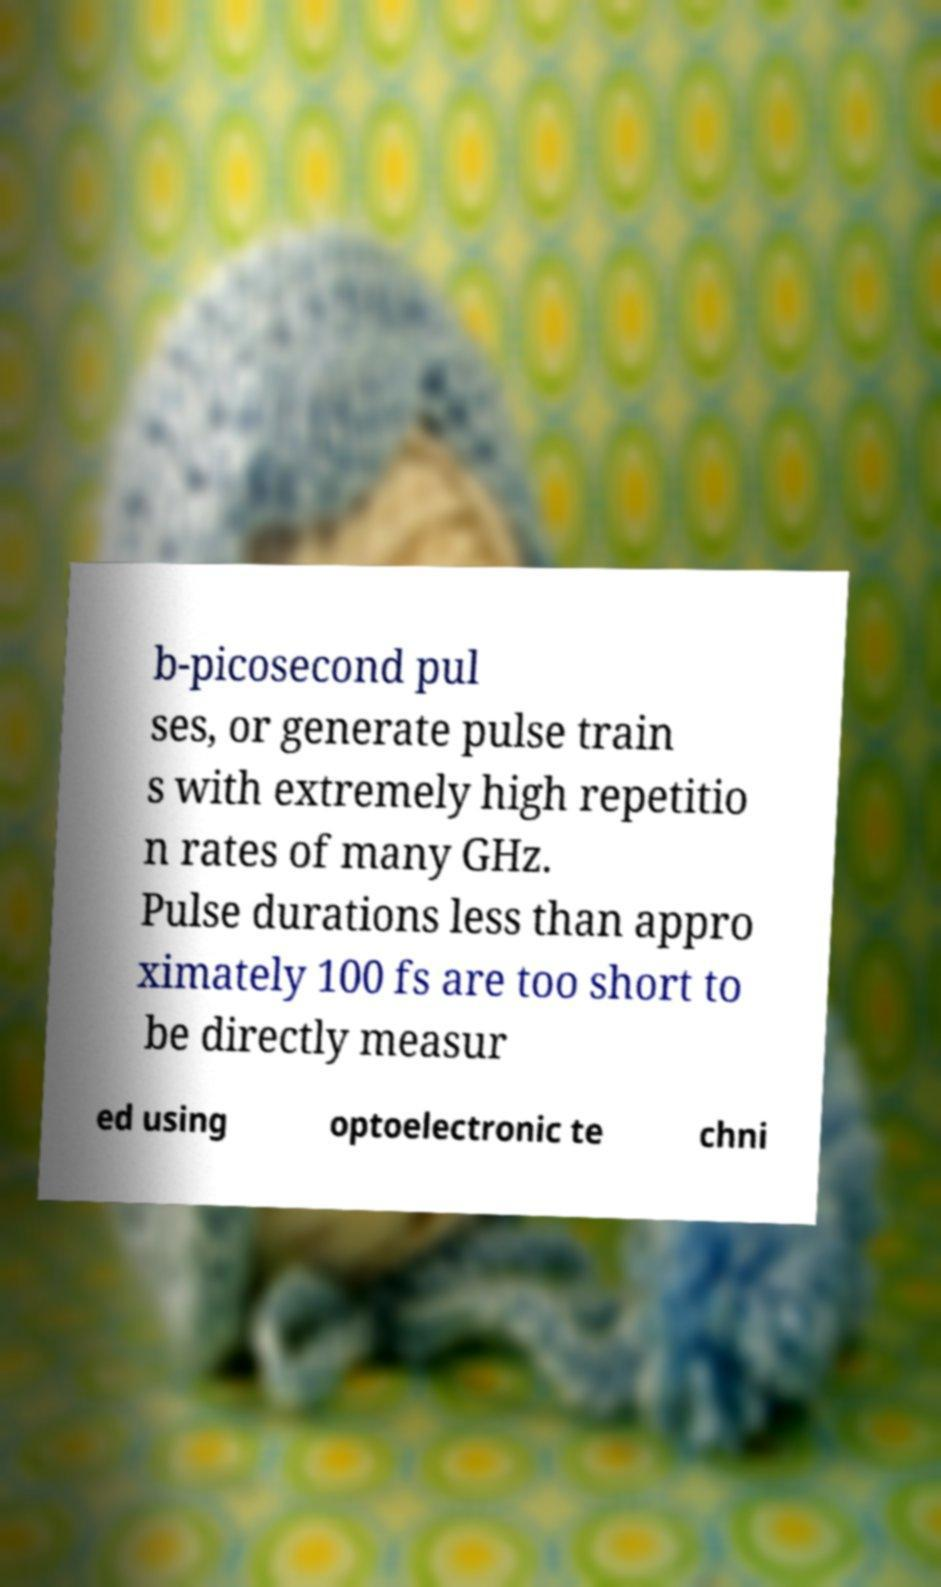For documentation purposes, I need the text within this image transcribed. Could you provide that? b-picosecond pul ses, or generate pulse train s with extremely high repetitio n rates of many GHz. Pulse durations less than appro ximately 100 fs are too short to be directly measur ed using optoelectronic te chni 